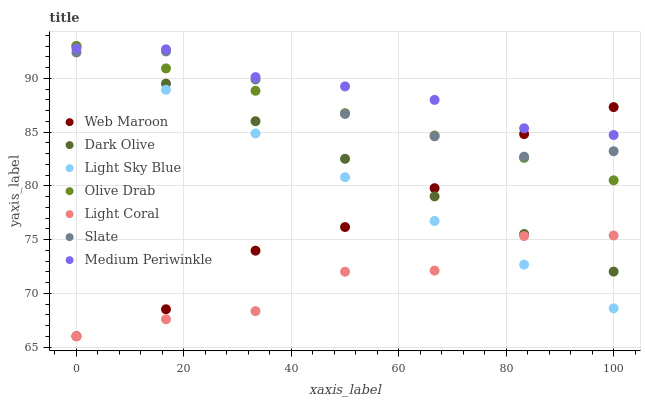Does Light Coral have the minimum area under the curve?
Answer yes or no. Yes. Does Medium Periwinkle have the maximum area under the curve?
Answer yes or no. Yes. Does Slate have the minimum area under the curve?
Answer yes or no. No. Does Slate have the maximum area under the curve?
Answer yes or no. No. Is Olive Drab the smoothest?
Answer yes or no. Yes. Is Light Coral the roughest?
Answer yes or no. Yes. Is Slate the smoothest?
Answer yes or no. No. Is Slate the roughest?
Answer yes or no. No. Does Web Maroon have the lowest value?
Answer yes or no. Yes. Does Slate have the lowest value?
Answer yes or no. No. Does Olive Drab have the highest value?
Answer yes or no. Yes. Does Slate have the highest value?
Answer yes or no. No. Is Light Coral less than Olive Drab?
Answer yes or no. Yes. Is Medium Periwinkle greater than Light Coral?
Answer yes or no. Yes. Does Light Sky Blue intersect Web Maroon?
Answer yes or no. Yes. Is Light Sky Blue less than Web Maroon?
Answer yes or no. No. Is Light Sky Blue greater than Web Maroon?
Answer yes or no. No. Does Light Coral intersect Olive Drab?
Answer yes or no. No. 